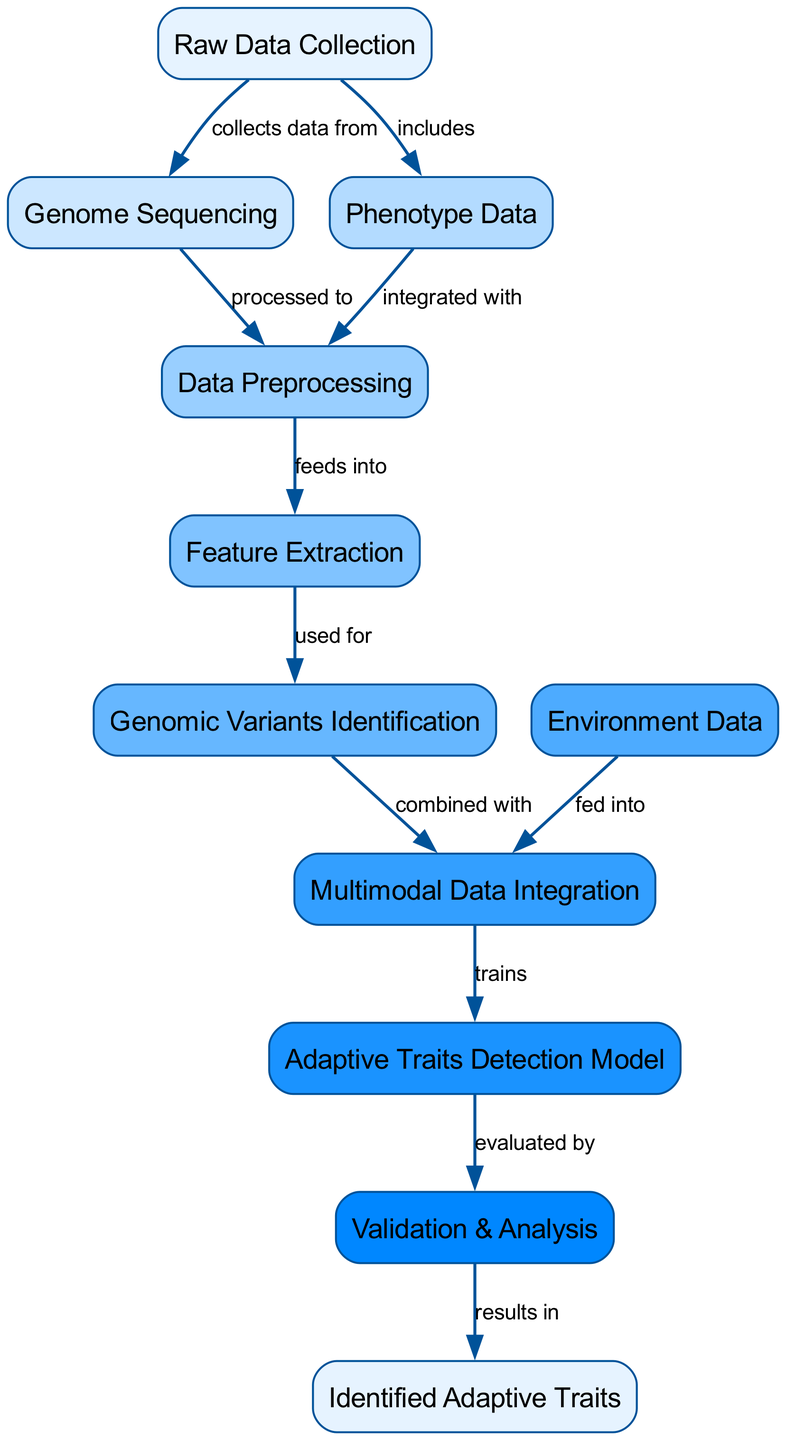What is the first step in the process? The first step is "Raw Data Collection," which is the initial node in the diagram. It does not receive input from any other processes, indicating it starts the workflow.
Answer: Raw Data Collection How many nodes are present in the diagram? By counting the nodes listed in the data, there are a total of 11 nodes that represent different stages in the process of adaptive traits identification.
Answer: 11 Which node is responsible for integrating phenotype data? The node responsible for integrating phenotype data is "Data Preprocessing," which combines data from both genome sequencing and phenotype data before moving on to the next step.
Answer: Data Preprocessing What are the nodes that "Multimodal Data Integration" receives data from? The "Multimodal Data Integration" node receives data from "Genomic Variants Identification" and "Environment Data," which are combined to form a multimodal dataset for further analysis.
Answer: Genomic Variants Identification, Environment Data What is the output of the "Adaptive Traits Detection Model"? The output of the "Adaptive Traits Detection Model" is the "Validation & Analysis" node, where the model is evaluated based on its performance after being trained on the integrated data.
Answer: Validation & Analysis How do "Genomic Variants Identification" and "Environment Data" contribute to the final adaptive traits? "Genomic Variants Identification" provides genomic insights, while "Environment Data" adds contextual information, both of which are combined in "Multimodal Data Integration" to formulate a model that detects adaptive traits.
Answer: Adaptive Traits Detection Model Which node concludes the analysis process? The analysis process concludes at the "Identified Adaptive Traits," which represents the final output after validation and evaluation of the model's predictions and findings.
Answer: Identified Adaptive Traits How is "Feature Extraction" related to "Data Preprocessing"? "Feature Extraction" directly follows "Data Preprocessing." It takes the cleaned and integrated data from the previous step and extracts relevant features that will be essential for identifying genomic variants.
Answer: feeds into What is the relationship between "Validation & Analysis" and "Identified Adaptive Traits"? "Validation & Analysis" is the process that results in "Identified Adaptive Traits," meaning it uses the model's evaluations to define which traits have been effectively identified based on the data analysis performed.
Answer: results in 